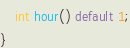Convert code to text. <code><loc_0><loc_0><loc_500><loc_500><_Java_>    int hour() default 1;
}
</code> 